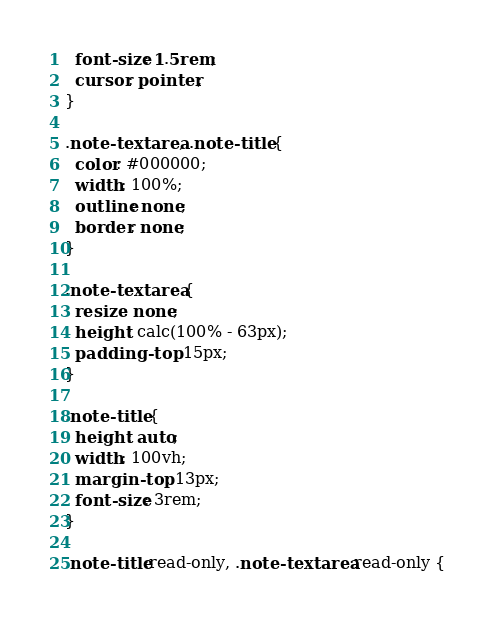<code> <loc_0><loc_0><loc_500><loc_500><_CSS_>  font-size: 1.5rem;
  cursor: pointer;
}

.note-textarea, .note-title {
  color: #000000;
  width: 100%;
  outline: none;
  border: none;
}

.note-textarea {
  resize: none;
  height: calc(100% - 63px);
  padding-top: 15px;
}

.note-title {
  height: auto;
  width: 100vh;
  margin-top: 13px;
  font-size: 3rem;
}

.note-title:read-only, .note-textarea:read-only {</code> 